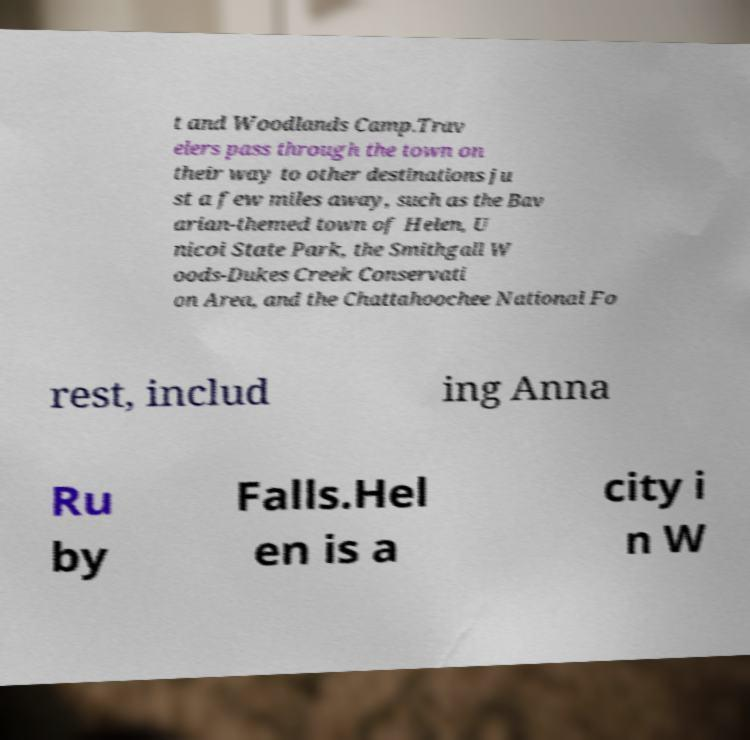Please identify and transcribe the text found in this image. t and Woodlands Camp.Trav elers pass through the town on their way to other destinations ju st a few miles away, such as the Bav arian-themed town of Helen, U nicoi State Park, the Smithgall W oods-Dukes Creek Conservati on Area, and the Chattahoochee National Fo rest, includ ing Anna Ru by Falls.Hel en is a city i n W 